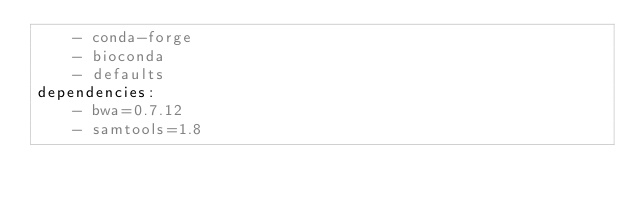Convert code to text. <code><loc_0><loc_0><loc_500><loc_500><_YAML_>    - conda-forge
    - bioconda
    - defaults
dependencies:
    - bwa=0.7.12
    - samtools=1.8
</code> 